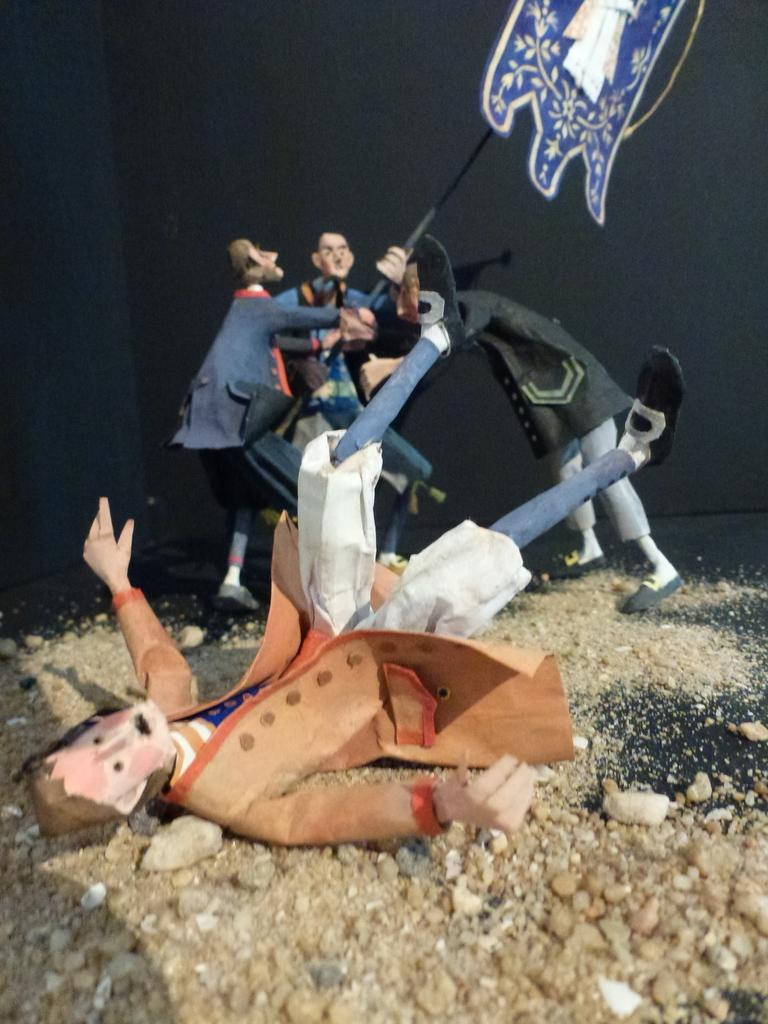What type of toys are present in the image? There are toys of people in the image. What is the surrounding environment of the toys? There is sand around the toys in the image. What type of thread is being used to sew the toys in the image? There is no thread or sewing visible in the image; the toys are already made and placed in the sand. 